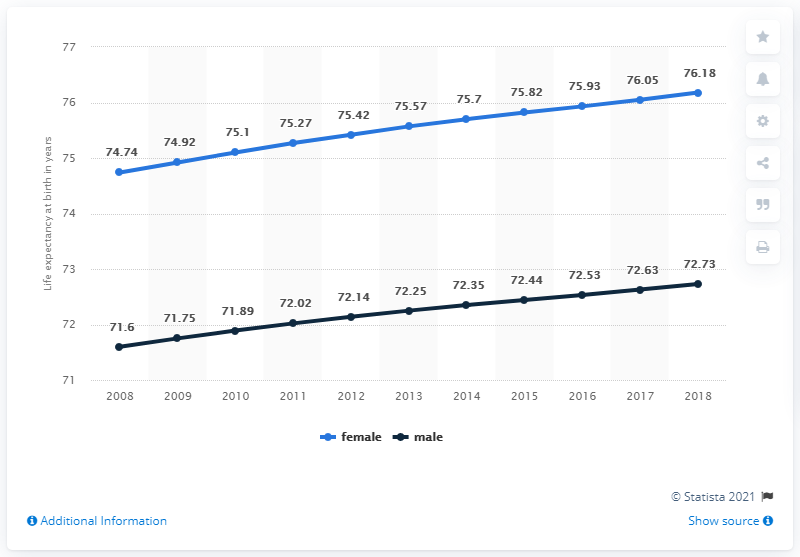Mention a couple of crucial points in this snapshot. According to data from the year 2017, female individuals had a higher life expectancy at birth compared to their male counterparts. The difference in female and male life expectancy at birth in the year 2011 was 3.25 years. 